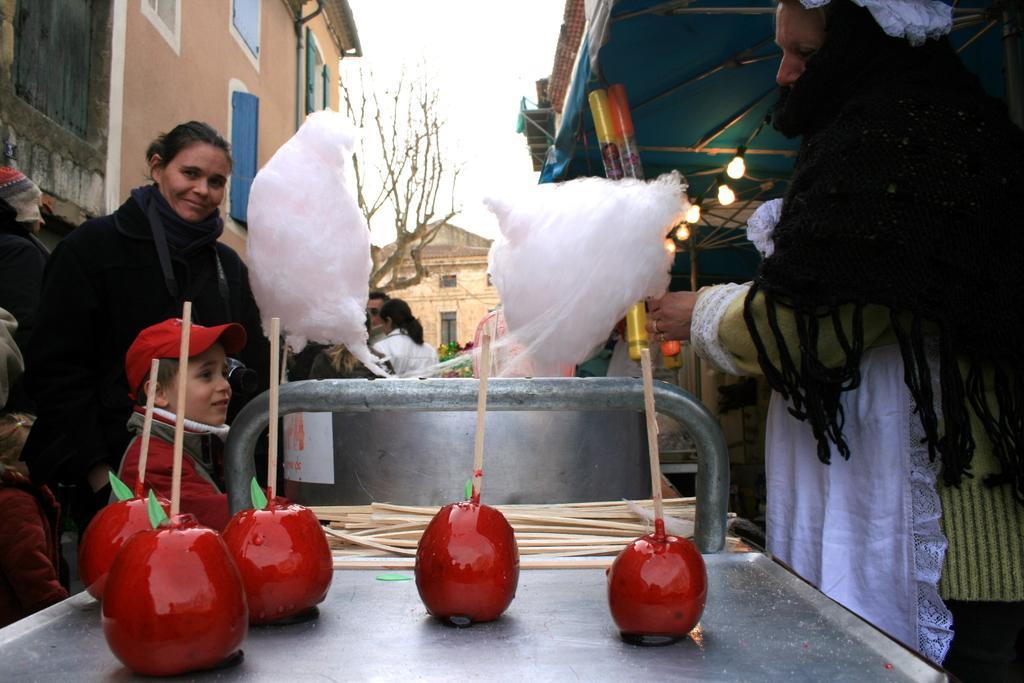Please provide a concise description of this image. In this image I can see few fruits in red color, background I can see few persons standing. I can also see a person holding a candy and I can see few lights, buildings in green, cream and white color, and the sky is in white color. 